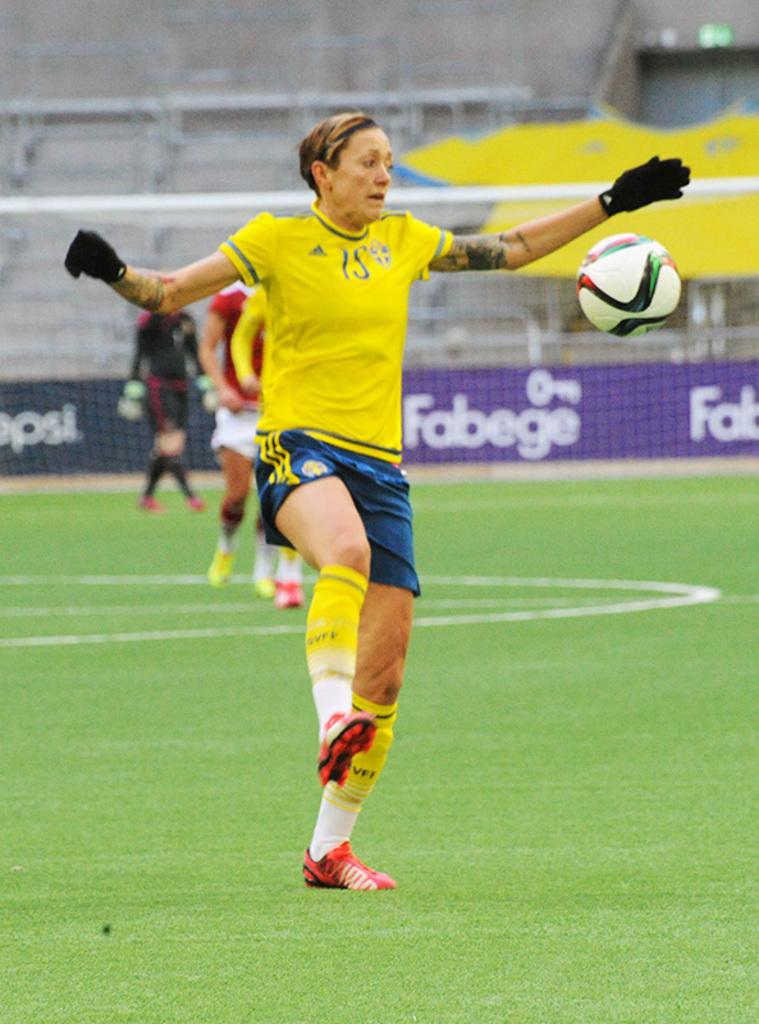What sport are the players engaged in within the image? The players are playing football in the image. Where is the football game taking place? The football game is taking place on a ground. What can be seen in the background of the image? There is fencing and a board with text in the background of the image. Can you read the text on the board? The text on the board is blurred, so it cannot be read. What type of plant is being played by the committee in the image? There is no plant or committee present in the image; it features a football game taking place on a ground. What musical instrument is being played by the players in the image? The players are not playing any musical instruments in the image; they are playing football. 